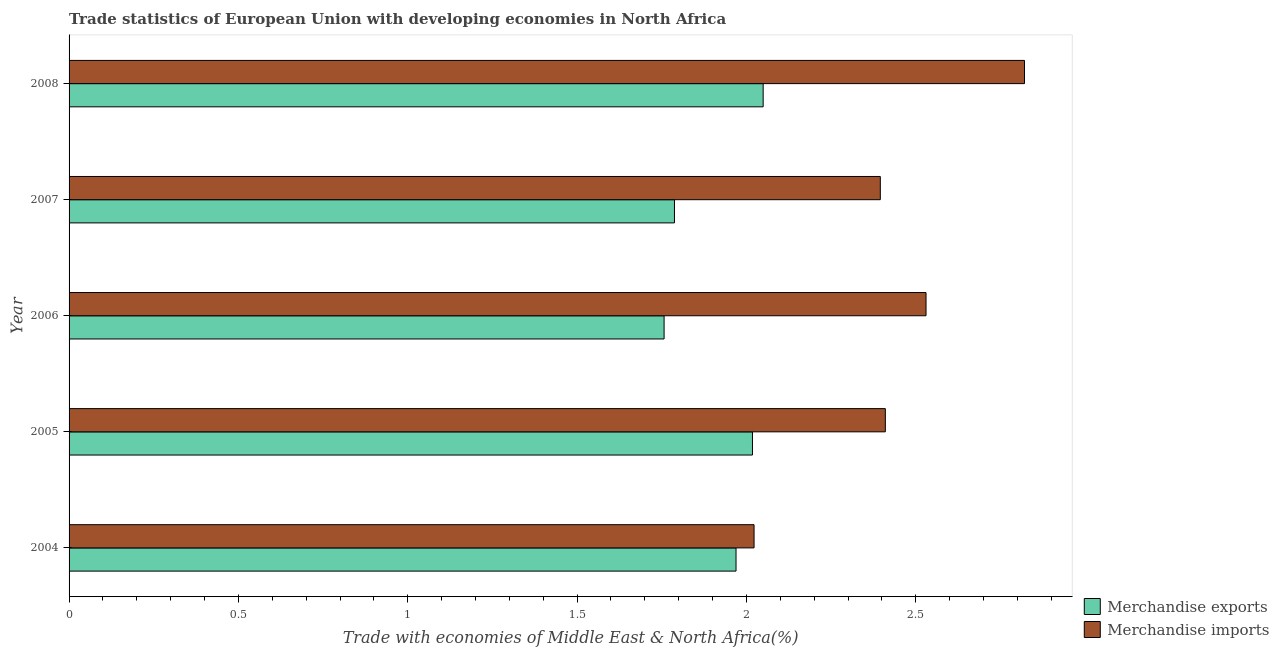How many groups of bars are there?
Keep it short and to the point. 5. Are the number of bars on each tick of the Y-axis equal?
Your response must be concise. Yes. How many bars are there on the 1st tick from the top?
Keep it short and to the point. 2. In how many cases, is the number of bars for a given year not equal to the number of legend labels?
Ensure brevity in your answer.  0. What is the merchandise exports in 2006?
Provide a succinct answer. 1.76. Across all years, what is the maximum merchandise imports?
Provide a succinct answer. 2.82. Across all years, what is the minimum merchandise exports?
Provide a short and direct response. 1.76. In which year was the merchandise imports minimum?
Your answer should be compact. 2004. What is the total merchandise imports in the graph?
Provide a short and direct response. 12.18. What is the difference between the merchandise exports in 2005 and that in 2007?
Ensure brevity in your answer.  0.23. What is the difference between the merchandise imports in 2007 and the merchandise exports in 2005?
Give a very brief answer. 0.38. What is the average merchandise exports per year?
Provide a short and direct response. 1.92. In the year 2005, what is the difference between the merchandise imports and merchandise exports?
Offer a terse response. 0.39. What is the ratio of the merchandise imports in 2005 to that in 2007?
Provide a succinct answer. 1.01. Is the merchandise exports in 2004 less than that in 2005?
Your answer should be compact. Yes. Is the difference between the merchandise exports in 2007 and 2008 greater than the difference between the merchandise imports in 2007 and 2008?
Your answer should be compact. Yes. What is the difference between the highest and the second highest merchandise exports?
Provide a succinct answer. 0.03. What is the difference between the highest and the lowest merchandise exports?
Give a very brief answer. 0.29. In how many years, is the merchandise exports greater than the average merchandise exports taken over all years?
Your answer should be compact. 3. Is the sum of the merchandise imports in 2004 and 2008 greater than the maximum merchandise exports across all years?
Offer a very short reply. Yes. What does the 2nd bar from the top in 2005 represents?
Provide a succinct answer. Merchandise exports. Are all the bars in the graph horizontal?
Provide a succinct answer. Yes. How many years are there in the graph?
Provide a short and direct response. 5. Does the graph contain any zero values?
Give a very brief answer. No. How many legend labels are there?
Offer a terse response. 2. How are the legend labels stacked?
Your answer should be very brief. Vertical. What is the title of the graph?
Your response must be concise. Trade statistics of European Union with developing economies in North Africa. Does "Residents" appear as one of the legend labels in the graph?
Your answer should be compact. No. What is the label or title of the X-axis?
Offer a very short reply. Trade with economies of Middle East & North Africa(%). What is the Trade with economies of Middle East & North Africa(%) in Merchandise exports in 2004?
Provide a short and direct response. 1.97. What is the Trade with economies of Middle East & North Africa(%) of Merchandise imports in 2004?
Your response must be concise. 2.02. What is the Trade with economies of Middle East & North Africa(%) of Merchandise exports in 2005?
Offer a terse response. 2.02. What is the Trade with economies of Middle East & North Africa(%) of Merchandise imports in 2005?
Offer a very short reply. 2.41. What is the Trade with economies of Middle East & North Africa(%) of Merchandise exports in 2006?
Offer a terse response. 1.76. What is the Trade with economies of Middle East & North Africa(%) in Merchandise imports in 2006?
Give a very brief answer. 2.53. What is the Trade with economies of Middle East & North Africa(%) of Merchandise exports in 2007?
Your response must be concise. 1.79. What is the Trade with economies of Middle East & North Africa(%) in Merchandise imports in 2007?
Ensure brevity in your answer.  2.4. What is the Trade with economies of Middle East & North Africa(%) of Merchandise exports in 2008?
Your answer should be compact. 2.05. What is the Trade with economies of Middle East & North Africa(%) in Merchandise imports in 2008?
Make the answer very short. 2.82. Across all years, what is the maximum Trade with economies of Middle East & North Africa(%) in Merchandise exports?
Offer a terse response. 2.05. Across all years, what is the maximum Trade with economies of Middle East & North Africa(%) of Merchandise imports?
Ensure brevity in your answer.  2.82. Across all years, what is the minimum Trade with economies of Middle East & North Africa(%) in Merchandise exports?
Your answer should be very brief. 1.76. Across all years, what is the minimum Trade with economies of Middle East & North Africa(%) in Merchandise imports?
Keep it short and to the point. 2.02. What is the total Trade with economies of Middle East & North Africa(%) of Merchandise exports in the graph?
Keep it short and to the point. 9.58. What is the total Trade with economies of Middle East & North Africa(%) in Merchandise imports in the graph?
Keep it short and to the point. 12.18. What is the difference between the Trade with economies of Middle East & North Africa(%) of Merchandise exports in 2004 and that in 2005?
Your answer should be compact. -0.05. What is the difference between the Trade with economies of Middle East & North Africa(%) of Merchandise imports in 2004 and that in 2005?
Make the answer very short. -0.39. What is the difference between the Trade with economies of Middle East & North Africa(%) of Merchandise exports in 2004 and that in 2006?
Keep it short and to the point. 0.21. What is the difference between the Trade with economies of Middle East & North Africa(%) in Merchandise imports in 2004 and that in 2006?
Keep it short and to the point. -0.51. What is the difference between the Trade with economies of Middle East & North Africa(%) in Merchandise exports in 2004 and that in 2007?
Offer a very short reply. 0.18. What is the difference between the Trade with economies of Middle East & North Africa(%) of Merchandise imports in 2004 and that in 2007?
Ensure brevity in your answer.  -0.37. What is the difference between the Trade with economies of Middle East & North Africa(%) in Merchandise exports in 2004 and that in 2008?
Provide a short and direct response. -0.08. What is the difference between the Trade with economies of Middle East & North Africa(%) of Merchandise imports in 2004 and that in 2008?
Make the answer very short. -0.8. What is the difference between the Trade with economies of Middle East & North Africa(%) in Merchandise exports in 2005 and that in 2006?
Make the answer very short. 0.26. What is the difference between the Trade with economies of Middle East & North Africa(%) in Merchandise imports in 2005 and that in 2006?
Provide a succinct answer. -0.12. What is the difference between the Trade with economies of Middle East & North Africa(%) of Merchandise exports in 2005 and that in 2007?
Keep it short and to the point. 0.23. What is the difference between the Trade with economies of Middle East & North Africa(%) of Merchandise imports in 2005 and that in 2007?
Provide a succinct answer. 0.01. What is the difference between the Trade with economies of Middle East & North Africa(%) of Merchandise exports in 2005 and that in 2008?
Make the answer very short. -0.03. What is the difference between the Trade with economies of Middle East & North Africa(%) in Merchandise imports in 2005 and that in 2008?
Your answer should be compact. -0.41. What is the difference between the Trade with economies of Middle East & North Africa(%) of Merchandise exports in 2006 and that in 2007?
Give a very brief answer. -0.03. What is the difference between the Trade with economies of Middle East & North Africa(%) of Merchandise imports in 2006 and that in 2007?
Provide a succinct answer. 0.14. What is the difference between the Trade with economies of Middle East & North Africa(%) of Merchandise exports in 2006 and that in 2008?
Your answer should be compact. -0.29. What is the difference between the Trade with economies of Middle East & North Africa(%) in Merchandise imports in 2006 and that in 2008?
Offer a very short reply. -0.29. What is the difference between the Trade with economies of Middle East & North Africa(%) in Merchandise exports in 2007 and that in 2008?
Your answer should be very brief. -0.26. What is the difference between the Trade with economies of Middle East & North Africa(%) of Merchandise imports in 2007 and that in 2008?
Provide a succinct answer. -0.43. What is the difference between the Trade with economies of Middle East & North Africa(%) of Merchandise exports in 2004 and the Trade with economies of Middle East & North Africa(%) of Merchandise imports in 2005?
Keep it short and to the point. -0.44. What is the difference between the Trade with economies of Middle East & North Africa(%) in Merchandise exports in 2004 and the Trade with economies of Middle East & North Africa(%) in Merchandise imports in 2006?
Provide a succinct answer. -0.56. What is the difference between the Trade with economies of Middle East & North Africa(%) of Merchandise exports in 2004 and the Trade with economies of Middle East & North Africa(%) of Merchandise imports in 2007?
Your answer should be very brief. -0.43. What is the difference between the Trade with economies of Middle East & North Africa(%) in Merchandise exports in 2004 and the Trade with economies of Middle East & North Africa(%) in Merchandise imports in 2008?
Make the answer very short. -0.85. What is the difference between the Trade with economies of Middle East & North Africa(%) of Merchandise exports in 2005 and the Trade with economies of Middle East & North Africa(%) of Merchandise imports in 2006?
Provide a short and direct response. -0.51. What is the difference between the Trade with economies of Middle East & North Africa(%) in Merchandise exports in 2005 and the Trade with economies of Middle East & North Africa(%) in Merchandise imports in 2007?
Your answer should be compact. -0.38. What is the difference between the Trade with economies of Middle East & North Africa(%) of Merchandise exports in 2005 and the Trade with economies of Middle East & North Africa(%) of Merchandise imports in 2008?
Keep it short and to the point. -0.8. What is the difference between the Trade with economies of Middle East & North Africa(%) of Merchandise exports in 2006 and the Trade with economies of Middle East & North Africa(%) of Merchandise imports in 2007?
Ensure brevity in your answer.  -0.64. What is the difference between the Trade with economies of Middle East & North Africa(%) of Merchandise exports in 2006 and the Trade with economies of Middle East & North Africa(%) of Merchandise imports in 2008?
Provide a short and direct response. -1.06. What is the difference between the Trade with economies of Middle East & North Africa(%) in Merchandise exports in 2007 and the Trade with economies of Middle East & North Africa(%) in Merchandise imports in 2008?
Provide a short and direct response. -1.03. What is the average Trade with economies of Middle East & North Africa(%) of Merchandise exports per year?
Provide a short and direct response. 1.92. What is the average Trade with economies of Middle East & North Africa(%) of Merchandise imports per year?
Provide a short and direct response. 2.44. In the year 2004, what is the difference between the Trade with economies of Middle East & North Africa(%) of Merchandise exports and Trade with economies of Middle East & North Africa(%) of Merchandise imports?
Your answer should be compact. -0.05. In the year 2005, what is the difference between the Trade with economies of Middle East & North Africa(%) of Merchandise exports and Trade with economies of Middle East & North Africa(%) of Merchandise imports?
Offer a terse response. -0.39. In the year 2006, what is the difference between the Trade with economies of Middle East & North Africa(%) of Merchandise exports and Trade with economies of Middle East & North Africa(%) of Merchandise imports?
Offer a very short reply. -0.77. In the year 2007, what is the difference between the Trade with economies of Middle East & North Africa(%) of Merchandise exports and Trade with economies of Middle East & North Africa(%) of Merchandise imports?
Your answer should be very brief. -0.61. In the year 2008, what is the difference between the Trade with economies of Middle East & North Africa(%) of Merchandise exports and Trade with economies of Middle East & North Africa(%) of Merchandise imports?
Offer a terse response. -0.77. What is the ratio of the Trade with economies of Middle East & North Africa(%) in Merchandise exports in 2004 to that in 2005?
Offer a very short reply. 0.98. What is the ratio of the Trade with economies of Middle East & North Africa(%) in Merchandise imports in 2004 to that in 2005?
Your response must be concise. 0.84. What is the ratio of the Trade with economies of Middle East & North Africa(%) of Merchandise exports in 2004 to that in 2006?
Offer a terse response. 1.12. What is the ratio of the Trade with economies of Middle East & North Africa(%) of Merchandise imports in 2004 to that in 2006?
Provide a succinct answer. 0.8. What is the ratio of the Trade with economies of Middle East & North Africa(%) in Merchandise exports in 2004 to that in 2007?
Keep it short and to the point. 1.1. What is the ratio of the Trade with economies of Middle East & North Africa(%) in Merchandise imports in 2004 to that in 2007?
Provide a short and direct response. 0.84. What is the ratio of the Trade with economies of Middle East & North Africa(%) of Merchandise exports in 2004 to that in 2008?
Your answer should be very brief. 0.96. What is the ratio of the Trade with economies of Middle East & North Africa(%) of Merchandise imports in 2004 to that in 2008?
Give a very brief answer. 0.72. What is the ratio of the Trade with economies of Middle East & North Africa(%) in Merchandise exports in 2005 to that in 2006?
Offer a terse response. 1.15. What is the ratio of the Trade with economies of Middle East & North Africa(%) in Merchandise imports in 2005 to that in 2006?
Keep it short and to the point. 0.95. What is the ratio of the Trade with economies of Middle East & North Africa(%) of Merchandise exports in 2005 to that in 2007?
Offer a very short reply. 1.13. What is the ratio of the Trade with economies of Middle East & North Africa(%) of Merchandise imports in 2005 to that in 2007?
Provide a succinct answer. 1.01. What is the ratio of the Trade with economies of Middle East & North Africa(%) of Merchandise exports in 2005 to that in 2008?
Your response must be concise. 0.98. What is the ratio of the Trade with economies of Middle East & North Africa(%) of Merchandise imports in 2005 to that in 2008?
Your response must be concise. 0.85. What is the ratio of the Trade with economies of Middle East & North Africa(%) in Merchandise exports in 2006 to that in 2007?
Your answer should be compact. 0.98. What is the ratio of the Trade with economies of Middle East & North Africa(%) of Merchandise imports in 2006 to that in 2007?
Keep it short and to the point. 1.06. What is the ratio of the Trade with economies of Middle East & North Africa(%) in Merchandise exports in 2006 to that in 2008?
Offer a very short reply. 0.86. What is the ratio of the Trade with economies of Middle East & North Africa(%) of Merchandise imports in 2006 to that in 2008?
Ensure brevity in your answer.  0.9. What is the ratio of the Trade with economies of Middle East & North Africa(%) of Merchandise exports in 2007 to that in 2008?
Give a very brief answer. 0.87. What is the ratio of the Trade with economies of Middle East & North Africa(%) in Merchandise imports in 2007 to that in 2008?
Your answer should be compact. 0.85. What is the difference between the highest and the second highest Trade with economies of Middle East & North Africa(%) in Merchandise exports?
Your answer should be compact. 0.03. What is the difference between the highest and the second highest Trade with economies of Middle East & North Africa(%) in Merchandise imports?
Offer a terse response. 0.29. What is the difference between the highest and the lowest Trade with economies of Middle East & North Africa(%) of Merchandise exports?
Make the answer very short. 0.29. What is the difference between the highest and the lowest Trade with economies of Middle East & North Africa(%) of Merchandise imports?
Keep it short and to the point. 0.8. 